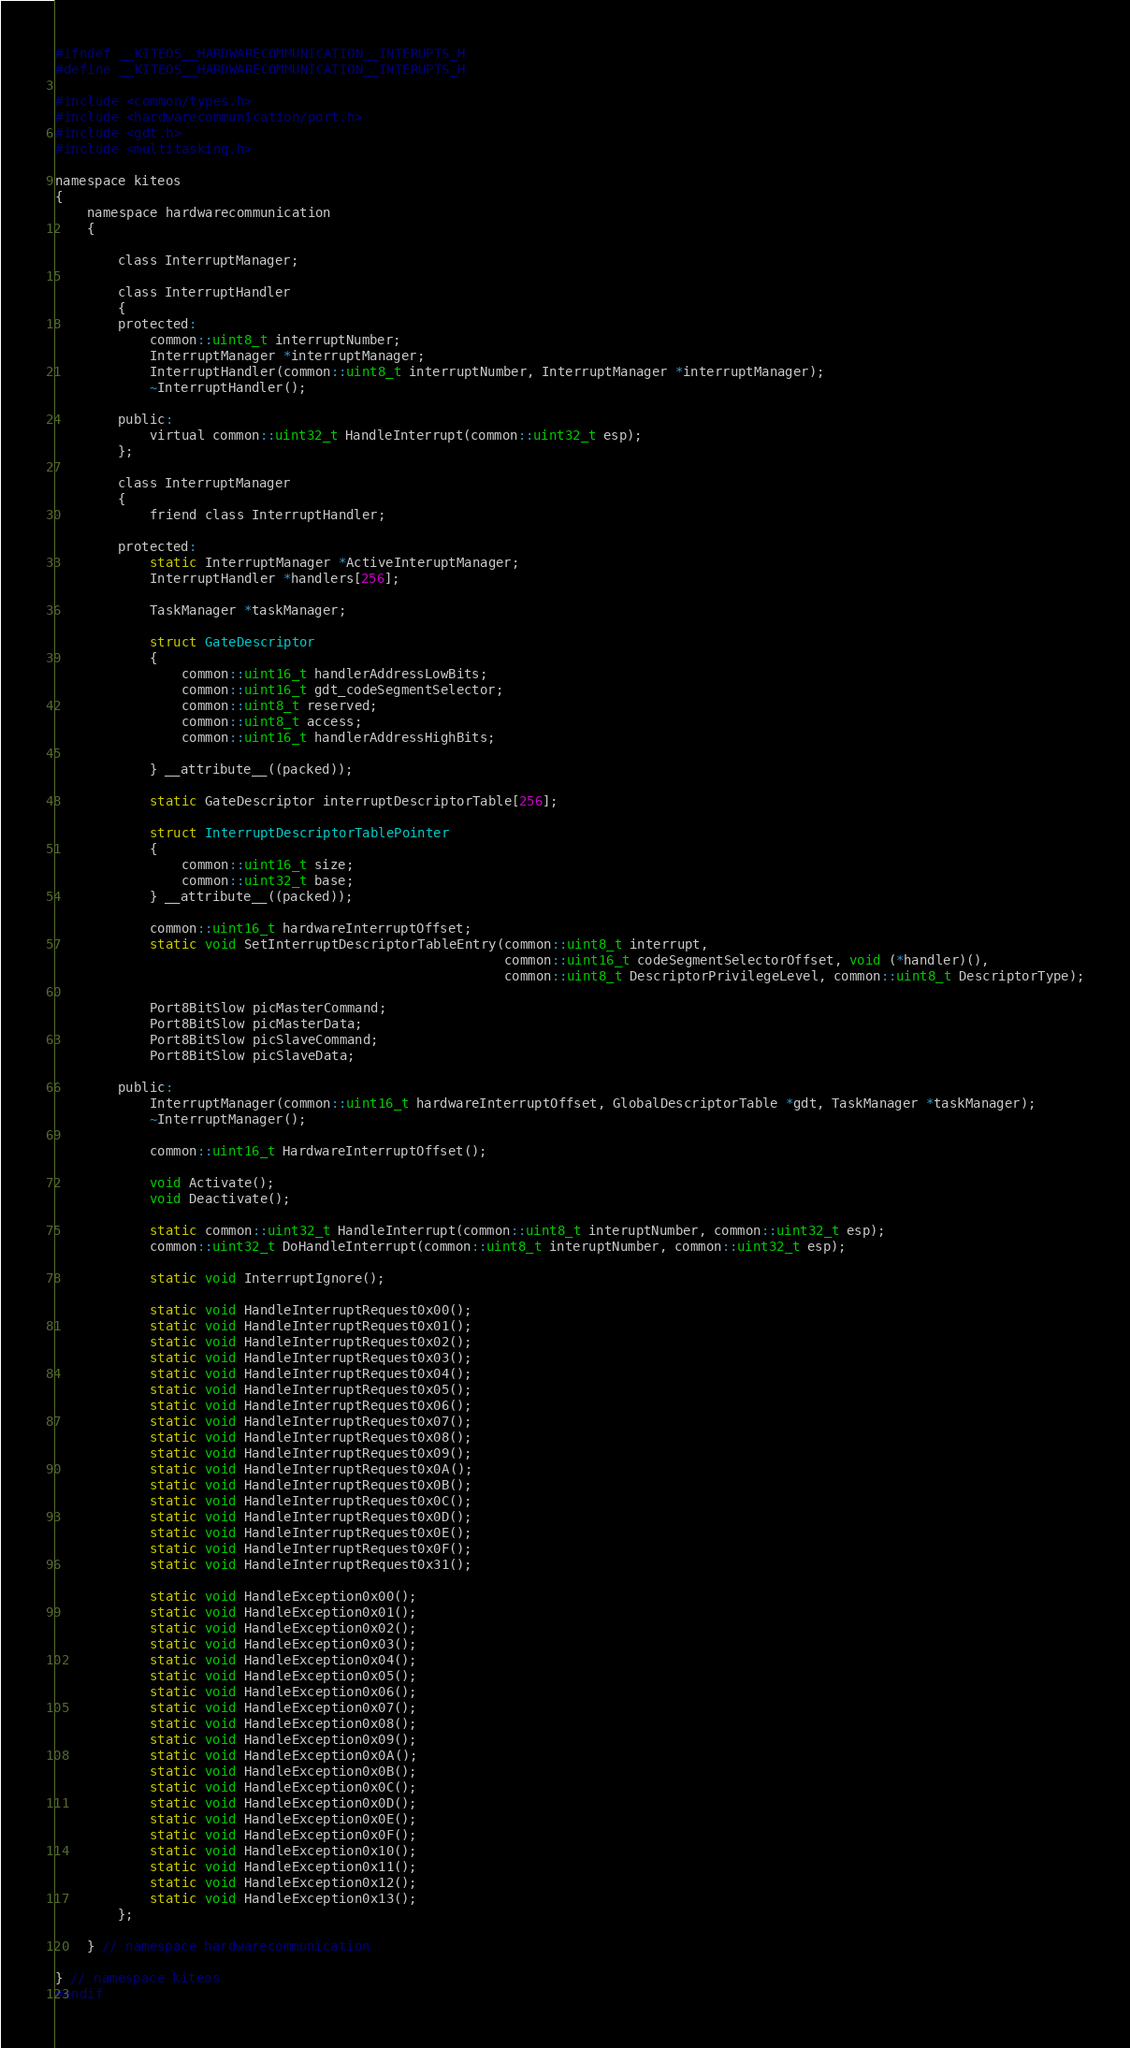<code> <loc_0><loc_0><loc_500><loc_500><_C_>#ifndef __KITEOS__HARDWARECOMMUNICATION__INTERUPTS_H
#define __KITEOS__HARDWARECOMMUNICATION__INTERUPTS_H

#include <common/types.h>
#include <hardwarecommunication/port.h>
#include <gdt.h>
#include <multitasking.h>

namespace kiteos
{
    namespace hardwarecommunication
    {

        class InterruptManager;

        class InterruptHandler
        {
        protected:
            common::uint8_t interruptNumber;
            InterruptManager *interruptManager;
            InterruptHandler(common::uint8_t interruptNumber, InterruptManager *interruptManager);
            ~InterruptHandler();

        public:
            virtual common::uint32_t HandleInterrupt(common::uint32_t esp);
        };

        class InterruptManager
        {
            friend class InterruptHandler;

        protected:
            static InterruptManager *ActiveInteruptManager;
            InterruptHandler *handlers[256];

            TaskManager *taskManager;

            struct GateDescriptor
            {
                common::uint16_t handlerAddressLowBits;
                common::uint16_t gdt_codeSegmentSelector;
                common::uint8_t reserved;
                common::uint8_t access;
                common::uint16_t handlerAddressHighBits;

            } __attribute__((packed));

            static GateDescriptor interruptDescriptorTable[256];

            struct InterruptDescriptorTablePointer
            {
                common::uint16_t size;
                common::uint32_t base;
            } __attribute__((packed));

            common::uint16_t hardwareInterruptOffset;
            static void SetInterruptDescriptorTableEntry(common::uint8_t interrupt,
                                                         common::uint16_t codeSegmentSelectorOffset, void (*handler)(),
                                                         common::uint8_t DescriptorPrivilegeLevel, common::uint8_t DescriptorType);

            Port8BitSlow picMasterCommand;
            Port8BitSlow picMasterData;
            Port8BitSlow picSlaveCommand;
            Port8BitSlow picSlaveData;

        public:
            InterruptManager(common::uint16_t hardwareInterruptOffset, GlobalDescriptorTable *gdt, TaskManager *taskManager);
            ~InterruptManager();

            common::uint16_t HardwareInterruptOffset();

            void Activate();
            void Deactivate();

            static common::uint32_t HandleInterrupt(common::uint8_t interuptNumber, common::uint32_t esp);
            common::uint32_t DoHandleInterrupt(common::uint8_t interuptNumber, common::uint32_t esp);

            static void InterruptIgnore();

            static void HandleInterruptRequest0x00();
            static void HandleInterruptRequest0x01();
            static void HandleInterruptRequest0x02();
            static void HandleInterruptRequest0x03();
            static void HandleInterruptRequest0x04();
            static void HandleInterruptRequest0x05();
            static void HandleInterruptRequest0x06();
            static void HandleInterruptRequest0x07();
            static void HandleInterruptRequest0x08();
            static void HandleInterruptRequest0x09();
            static void HandleInterruptRequest0x0A();
            static void HandleInterruptRequest0x0B();
            static void HandleInterruptRequest0x0C();
            static void HandleInterruptRequest0x0D();
            static void HandleInterruptRequest0x0E();
            static void HandleInterruptRequest0x0F();
            static void HandleInterruptRequest0x31();

            static void HandleException0x00();
            static void HandleException0x01();
            static void HandleException0x02();
            static void HandleException0x03();
            static void HandleException0x04();
            static void HandleException0x05();
            static void HandleException0x06();
            static void HandleException0x07();
            static void HandleException0x08();
            static void HandleException0x09();
            static void HandleException0x0A();
            static void HandleException0x0B();
            static void HandleException0x0C();
            static void HandleException0x0D();
            static void HandleException0x0E();
            static void HandleException0x0F();
            static void HandleException0x10();
            static void HandleException0x11();
            static void HandleException0x12();
            static void HandleException0x13();
        };

    } // namespace hardwarecommunication

} // namespace kiteos
#endif
</code> 